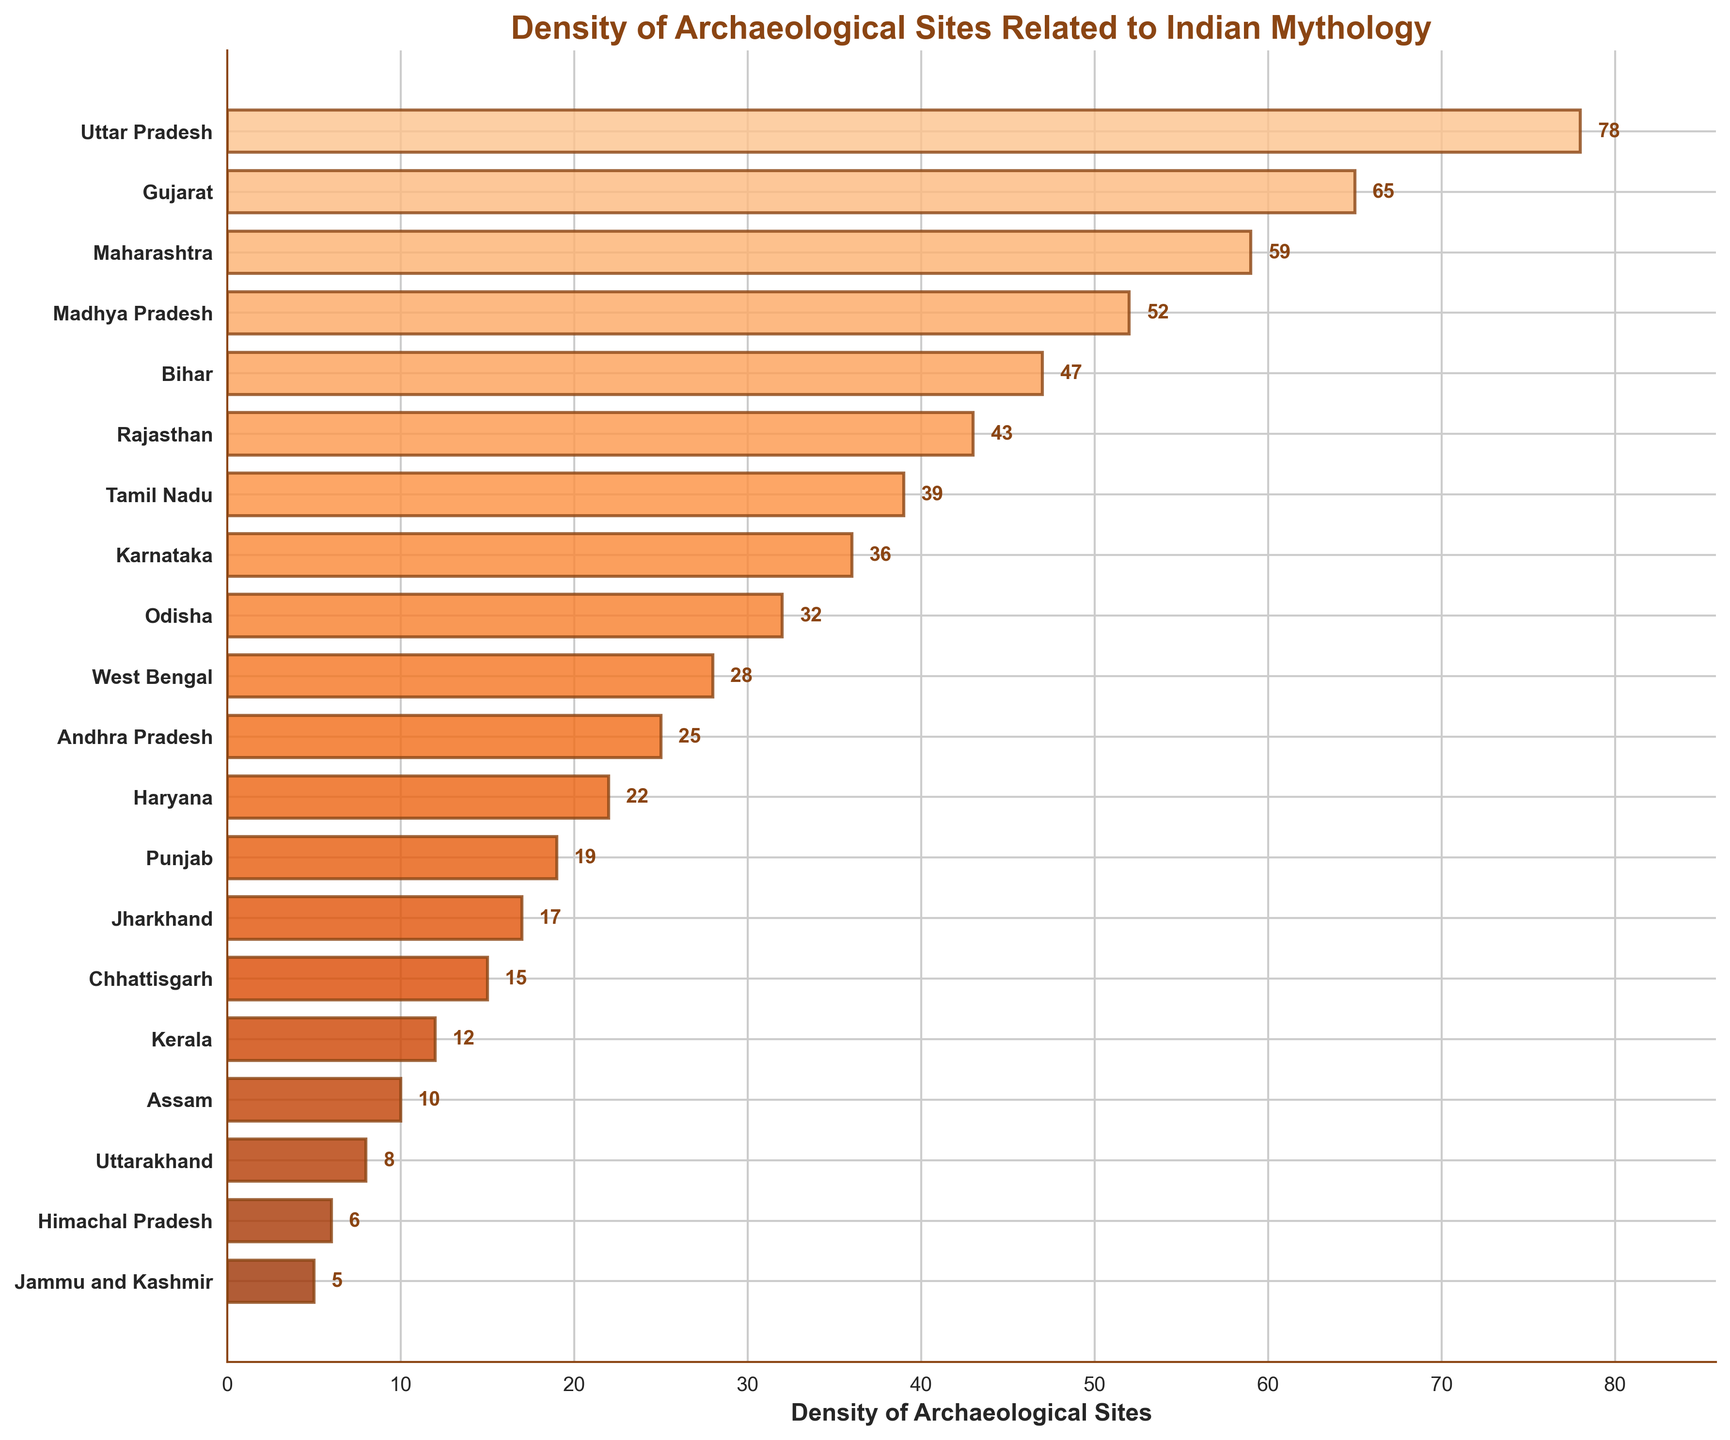What is the title of this plot? The title is located at the top of the plot, where it is clearly visible in bold letters.
Answer: Density of Archaeological Sites Related to Indian Mythology Which state has the highest density of archaeological sites? By observing the bars representing each state, the longest bar corresponds to Uttar Pradesh.
Answer: Uttar Pradesh Which two states have densities just below and above Maharashtra? Maharashtra has a density of 59. The bars closest to Maharashtra are Madhya Pradesh (below with 52) and Gujarat (above with 65).
Answer: Madhya Pradesh, Gujarat What is the difference in archaeological site density between Tamil Nadu and Odisha? Tamil Nadu's density is 39, and Odisha's density is 32. Subtract 32 from 39 to find the difference.
Answer: 7 List the states with an archaeological site density higher than 50. Bars that extend beyond the 50 mark represent Uttar Pradesh, Gujarat, and Maharashtra.
Answer: Uttar Pradesh, Gujarat, Maharashtra If you average the densities of Karnataka and Kerala, what is the result? Karnataka has a density of 36, and Kerala has a density of 12. Sum them (36 + 12 = 48) and divide by 2.
Answer: 24 Which state has the lowest density of archaeological sites? The shortest bar represents Jammu and Kashmir.
Answer: Jammu and Kashmir What is the combined density of Haryana and Punjab? Haryana has a density of 22 and Punjab has a density of 19. Add the two values together (22 + 19 = 41).
Answer: 41 How many states have a density of archaeological sites less than 20? Counting the bars with values less than 20, there are six states: Punjab, Jharkhand, Chhattisgarh, Kerala, Assam, and Uttarakhand.
Answer: 6 Which state has a smaller density of archaeological sites, Assam or Uttarakhand? Comparing the bars for Assam (10) and Uttarakhand (8), Uttarakhand has a smaller density.
Answer: Uttarakhand 